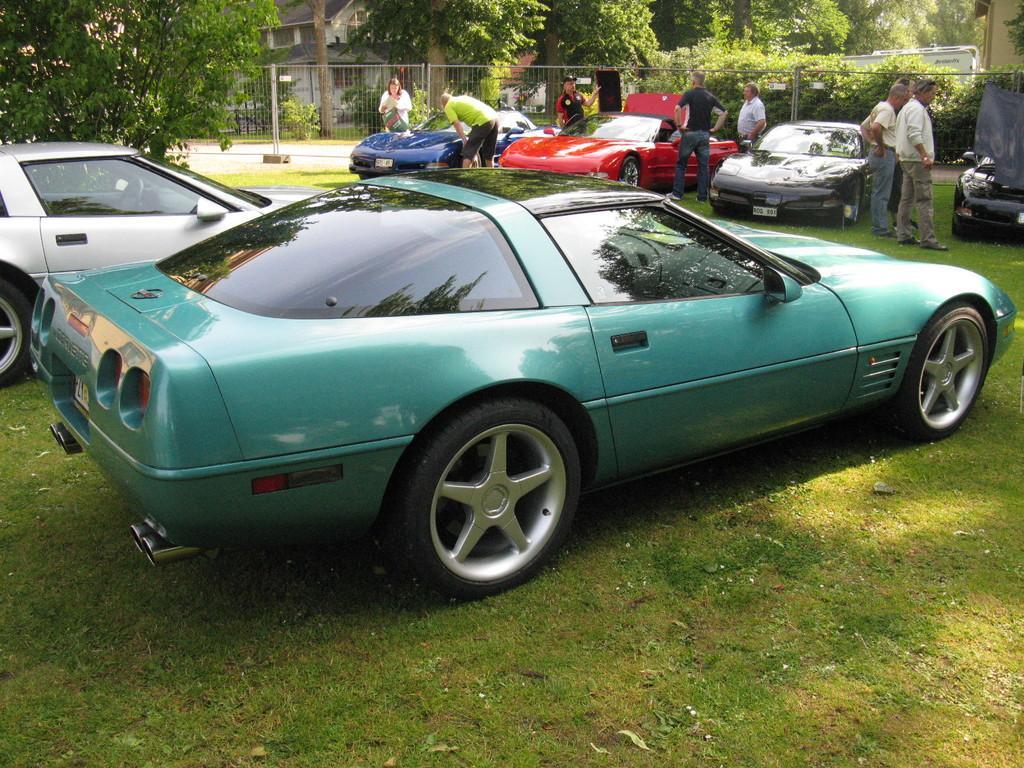Could you give a brief overview of what you see in this image? In this image I see 6 cars which are of different colors and few persons near to the cars and I see the green grass. In the background I see the trees, few buildings and the path. 